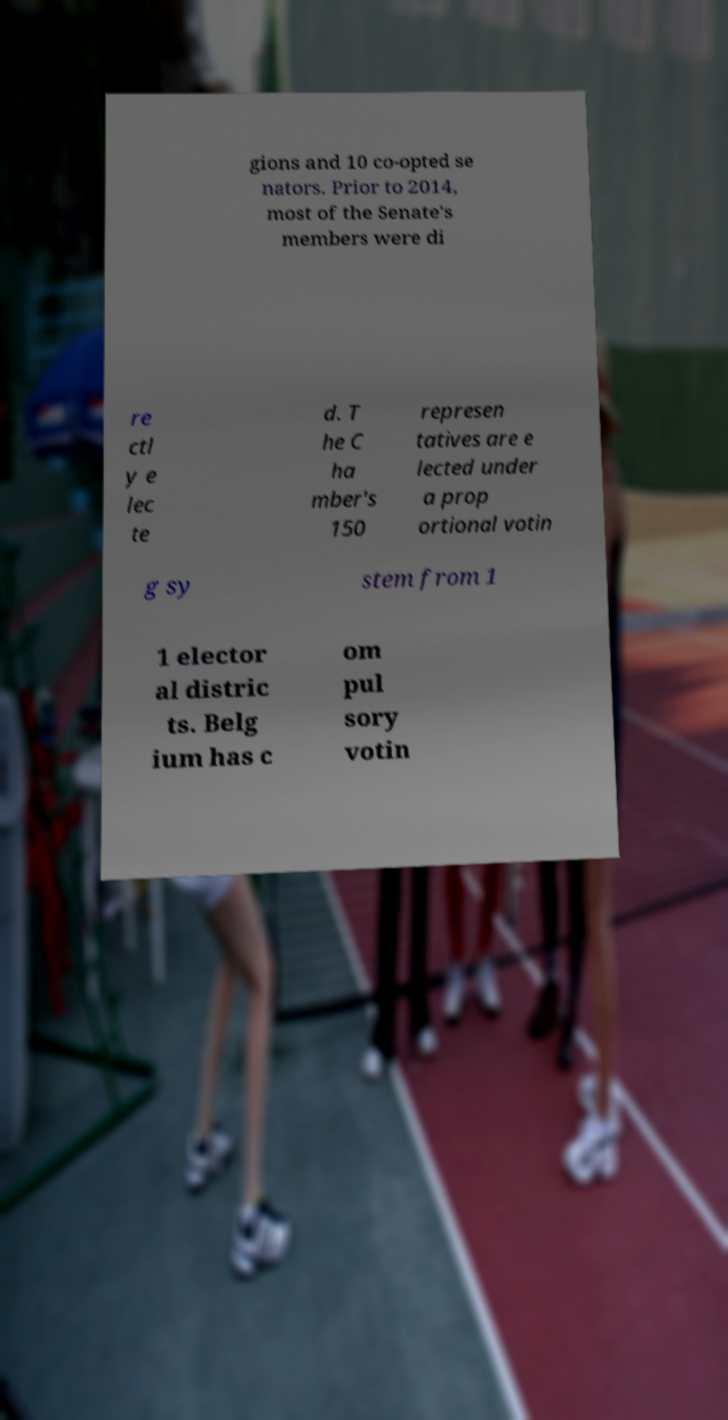What messages or text are displayed in this image? I need them in a readable, typed format. gions and 10 co-opted se nators. Prior to 2014, most of the Senate's members were di re ctl y e lec te d. T he C ha mber's 150 represen tatives are e lected under a prop ortional votin g sy stem from 1 1 elector al distric ts. Belg ium has c om pul sory votin 